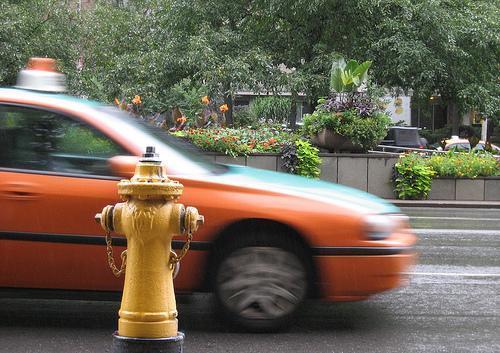How many fire hydrants can be seen?
Give a very brief answer. 1. 